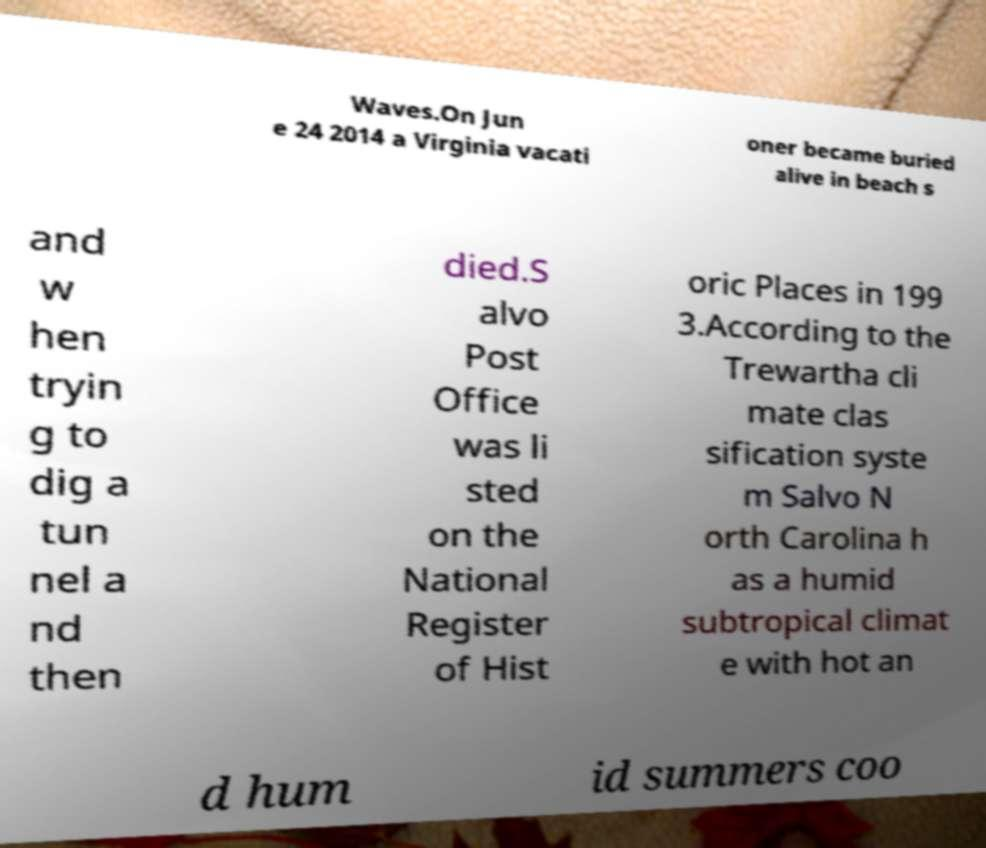Please read and relay the text visible in this image. What does it say? Waves.On Jun e 24 2014 a Virginia vacati oner became buried alive in beach s and w hen tryin g to dig a tun nel a nd then died.S alvo Post Office was li sted on the National Register of Hist oric Places in 199 3.According to the Trewartha cli mate clas sification syste m Salvo N orth Carolina h as a humid subtropical climat e with hot an d hum id summers coo 